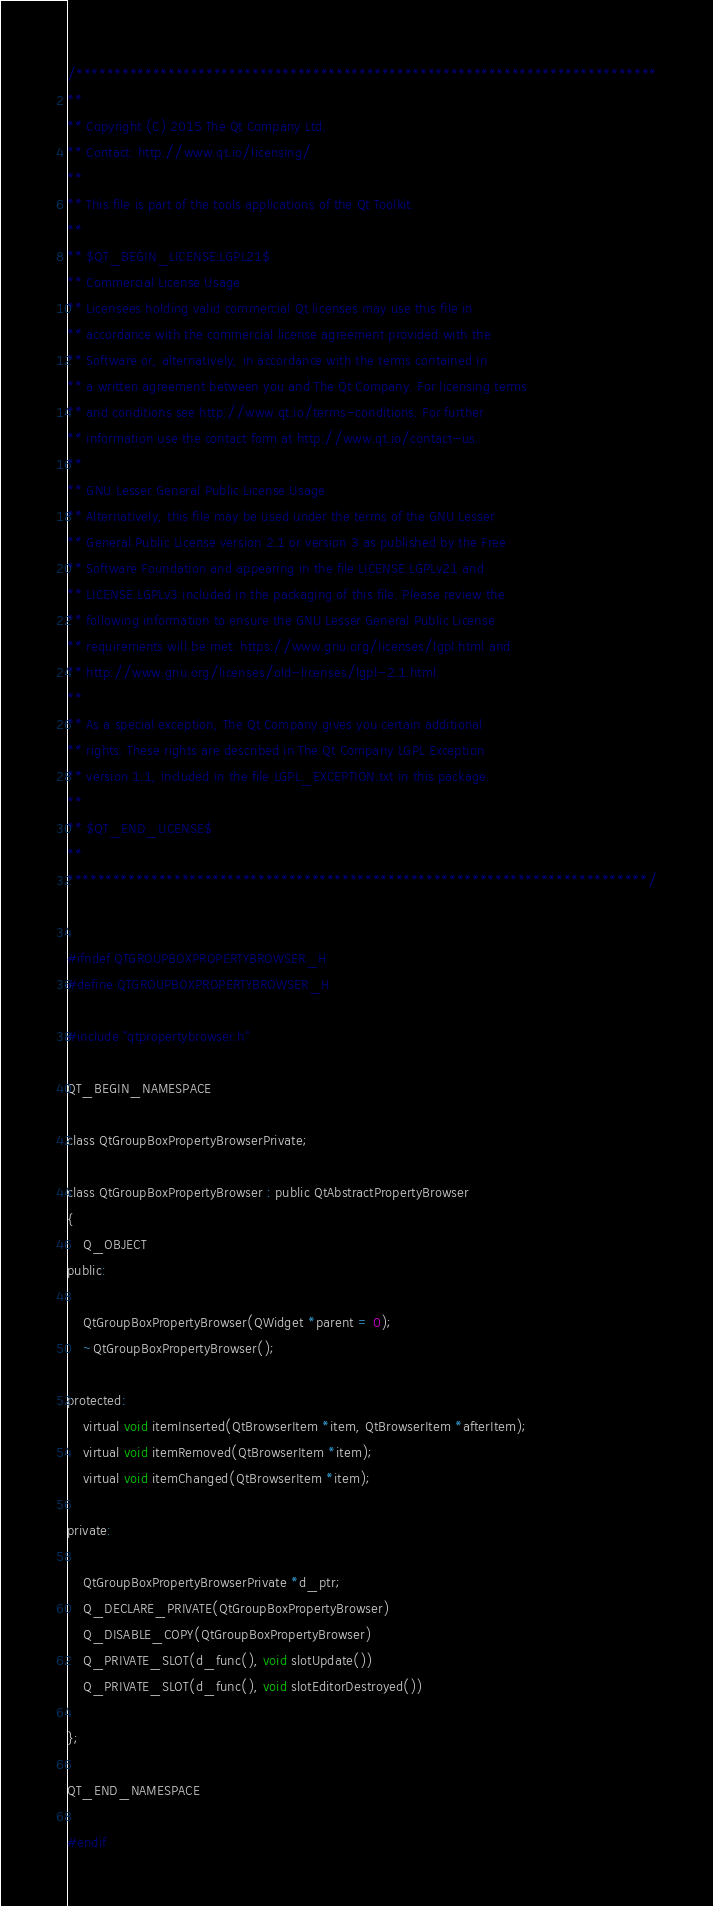<code> <loc_0><loc_0><loc_500><loc_500><_C_>/****************************************************************************
**
** Copyright (C) 2015 The Qt Company Ltd.
** Contact: http://www.qt.io/licensing/
**
** This file is part of the tools applications of the Qt Toolkit.
**
** $QT_BEGIN_LICENSE:LGPL21$
** Commercial License Usage
** Licensees holding valid commercial Qt licenses may use this file in
** accordance with the commercial license agreement provided with the
** Software or, alternatively, in accordance with the terms contained in
** a written agreement between you and The Qt Company. For licensing terms
** and conditions see http://www.qt.io/terms-conditions. For further
** information use the contact form at http://www.qt.io/contact-us.
**
** GNU Lesser General Public License Usage
** Alternatively, this file may be used under the terms of the GNU Lesser
** General Public License version 2.1 or version 3 as published by the Free
** Software Foundation and appearing in the file LICENSE.LGPLv21 and
** LICENSE.LGPLv3 included in the packaging of this file. Please review the
** following information to ensure the GNU Lesser General Public License
** requirements will be met: https://www.gnu.org/licenses/lgpl.html and
** http://www.gnu.org/licenses/old-licenses/lgpl-2.1.html.
**
** As a special exception, The Qt Company gives you certain additional
** rights. These rights are described in The Qt Company LGPL Exception
** version 1.1, included in the file LGPL_EXCEPTION.txt in this package.
**
** $QT_END_LICENSE$
**
****************************************************************************/


#ifndef QTGROUPBOXPROPERTYBROWSER_H
#define QTGROUPBOXPROPERTYBROWSER_H

#include "qtpropertybrowser.h"

QT_BEGIN_NAMESPACE

class QtGroupBoxPropertyBrowserPrivate;

class QtGroupBoxPropertyBrowser : public QtAbstractPropertyBrowser
{
    Q_OBJECT
public:

    QtGroupBoxPropertyBrowser(QWidget *parent = 0);
    ~QtGroupBoxPropertyBrowser();

protected:
    virtual void itemInserted(QtBrowserItem *item, QtBrowserItem *afterItem);
    virtual void itemRemoved(QtBrowserItem *item);
    virtual void itemChanged(QtBrowserItem *item);

private:

    QtGroupBoxPropertyBrowserPrivate *d_ptr;
    Q_DECLARE_PRIVATE(QtGroupBoxPropertyBrowser)
    Q_DISABLE_COPY(QtGroupBoxPropertyBrowser)
    Q_PRIVATE_SLOT(d_func(), void slotUpdate())
    Q_PRIVATE_SLOT(d_func(), void slotEditorDestroyed())

};

QT_END_NAMESPACE

#endif
</code> 